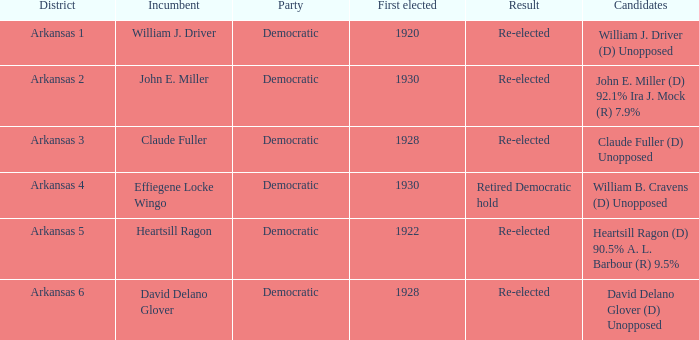Who ran in the election where Claude Fuller was the incumbent?  Claude Fuller (D) Unopposed. 